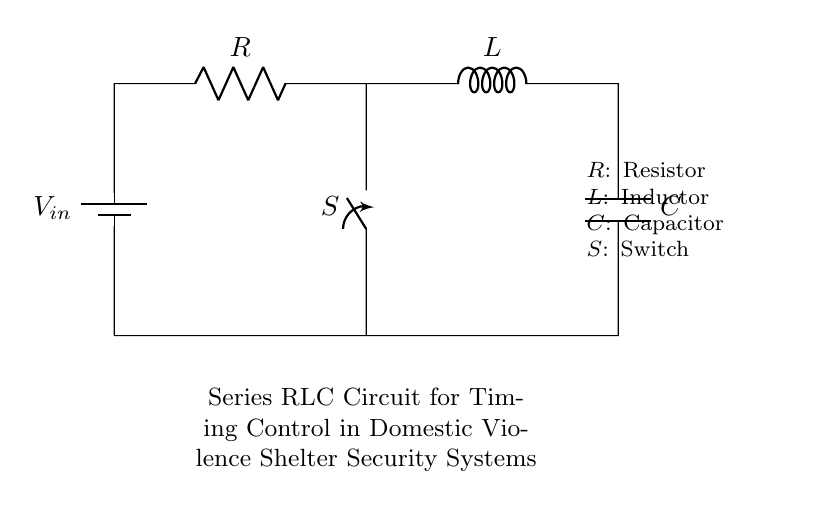What components are in the circuit? The circuit consists of a resistor, an inductor, a capacitor, a switch, and a battery. These components are connected in series, forming a single loop.
Answer: Resistor, Inductor, Capacitor, Switch, Battery What type of circuit is this? This is a series RLC circuit, where the resistor, inductor, and capacitor are connected in a series arrangement. This configuration allows for specific timing control.
Answer: Series RLC circuit What role does the switch play in this circuit? The switch provides the ability to open or close the circuit, which can control the timing of the current through the components. When closed, it allows current to flow, affecting the timing characteristics defined by the RLC elements.
Answer: Timing control What is the purpose of this RLC circuit in domestic violence shelters? The purpose is to regulate the timing for triggering alarms or lights, which can enhance security measures to protect individuals in shelters. A specific time delay can provide critical moments for safety.
Answer: Timing control in security How does the inductor affect the circuit's behavior? The inductor stores energy in the form of a magnetic field when current flows through it. It affects the timing and phase of the current and voltage in the circuit, leading to applications where delay or smoothing of the signal is needed.
Answer: Delays current What is the significance of the capacitor in this circuit? The capacitor stores and releases electrical energy, helping to smooth out voltage fluctuations and stabilize the circuit. Its charge-discharge behavior contributes to the timing delay in the circuit operation.
Answer: Energy storage 